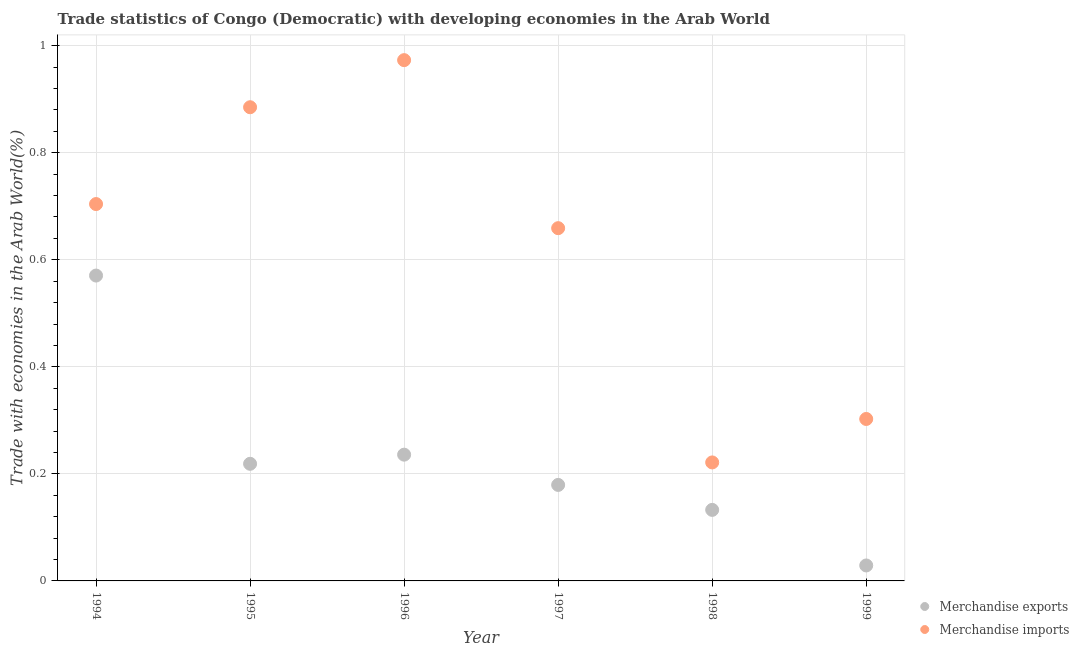What is the merchandise exports in 1999?
Your answer should be very brief. 0.03. Across all years, what is the maximum merchandise imports?
Your answer should be compact. 0.97. Across all years, what is the minimum merchandise exports?
Make the answer very short. 0.03. In which year was the merchandise exports minimum?
Offer a terse response. 1999. What is the total merchandise imports in the graph?
Provide a succinct answer. 3.75. What is the difference between the merchandise imports in 1998 and that in 1999?
Offer a very short reply. -0.08. What is the difference between the merchandise exports in 1994 and the merchandise imports in 1999?
Your answer should be very brief. 0.27. What is the average merchandise exports per year?
Provide a succinct answer. 0.23. In the year 1995, what is the difference between the merchandise exports and merchandise imports?
Your answer should be compact. -0.67. What is the ratio of the merchandise exports in 1996 to that in 1997?
Offer a terse response. 1.32. Is the merchandise imports in 1998 less than that in 1999?
Your answer should be very brief. Yes. What is the difference between the highest and the second highest merchandise imports?
Make the answer very short. 0.09. What is the difference between the highest and the lowest merchandise exports?
Provide a short and direct response. 0.54. Is the sum of the merchandise imports in 1994 and 1998 greater than the maximum merchandise exports across all years?
Offer a very short reply. Yes. Does the merchandise exports monotonically increase over the years?
Offer a very short reply. No. Is the merchandise exports strictly greater than the merchandise imports over the years?
Offer a very short reply. No. How many dotlines are there?
Your response must be concise. 2. How many years are there in the graph?
Make the answer very short. 6. What is the difference between two consecutive major ticks on the Y-axis?
Provide a succinct answer. 0.2. Does the graph contain any zero values?
Provide a short and direct response. No. How many legend labels are there?
Make the answer very short. 2. How are the legend labels stacked?
Provide a succinct answer. Vertical. What is the title of the graph?
Your answer should be compact. Trade statistics of Congo (Democratic) with developing economies in the Arab World. Does "Tetanus" appear as one of the legend labels in the graph?
Your response must be concise. No. What is the label or title of the Y-axis?
Your answer should be very brief. Trade with economies in the Arab World(%). What is the Trade with economies in the Arab World(%) of Merchandise exports in 1994?
Offer a very short reply. 0.57. What is the Trade with economies in the Arab World(%) of Merchandise imports in 1994?
Provide a succinct answer. 0.7. What is the Trade with economies in the Arab World(%) of Merchandise exports in 1995?
Ensure brevity in your answer.  0.22. What is the Trade with economies in the Arab World(%) of Merchandise imports in 1995?
Make the answer very short. 0.89. What is the Trade with economies in the Arab World(%) of Merchandise exports in 1996?
Ensure brevity in your answer.  0.24. What is the Trade with economies in the Arab World(%) in Merchandise imports in 1996?
Offer a terse response. 0.97. What is the Trade with economies in the Arab World(%) in Merchandise exports in 1997?
Offer a very short reply. 0.18. What is the Trade with economies in the Arab World(%) of Merchandise imports in 1997?
Offer a very short reply. 0.66. What is the Trade with economies in the Arab World(%) in Merchandise exports in 1998?
Offer a very short reply. 0.13. What is the Trade with economies in the Arab World(%) in Merchandise imports in 1998?
Your answer should be compact. 0.22. What is the Trade with economies in the Arab World(%) in Merchandise exports in 1999?
Your answer should be very brief. 0.03. What is the Trade with economies in the Arab World(%) of Merchandise imports in 1999?
Provide a succinct answer. 0.3. Across all years, what is the maximum Trade with economies in the Arab World(%) of Merchandise exports?
Keep it short and to the point. 0.57. Across all years, what is the maximum Trade with economies in the Arab World(%) of Merchandise imports?
Your answer should be compact. 0.97. Across all years, what is the minimum Trade with economies in the Arab World(%) in Merchandise exports?
Offer a terse response. 0.03. Across all years, what is the minimum Trade with economies in the Arab World(%) of Merchandise imports?
Offer a very short reply. 0.22. What is the total Trade with economies in the Arab World(%) of Merchandise exports in the graph?
Provide a succinct answer. 1.37. What is the total Trade with economies in the Arab World(%) of Merchandise imports in the graph?
Make the answer very short. 3.75. What is the difference between the Trade with economies in the Arab World(%) of Merchandise exports in 1994 and that in 1995?
Make the answer very short. 0.35. What is the difference between the Trade with economies in the Arab World(%) in Merchandise imports in 1994 and that in 1995?
Offer a very short reply. -0.18. What is the difference between the Trade with economies in the Arab World(%) in Merchandise exports in 1994 and that in 1996?
Your response must be concise. 0.33. What is the difference between the Trade with economies in the Arab World(%) of Merchandise imports in 1994 and that in 1996?
Keep it short and to the point. -0.27. What is the difference between the Trade with economies in the Arab World(%) of Merchandise exports in 1994 and that in 1997?
Offer a terse response. 0.39. What is the difference between the Trade with economies in the Arab World(%) in Merchandise imports in 1994 and that in 1997?
Your answer should be compact. 0.04. What is the difference between the Trade with economies in the Arab World(%) of Merchandise exports in 1994 and that in 1998?
Give a very brief answer. 0.44. What is the difference between the Trade with economies in the Arab World(%) of Merchandise imports in 1994 and that in 1998?
Provide a succinct answer. 0.48. What is the difference between the Trade with economies in the Arab World(%) of Merchandise exports in 1994 and that in 1999?
Give a very brief answer. 0.54. What is the difference between the Trade with economies in the Arab World(%) in Merchandise imports in 1994 and that in 1999?
Make the answer very short. 0.4. What is the difference between the Trade with economies in the Arab World(%) in Merchandise exports in 1995 and that in 1996?
Your answer should be compact. -0.02. What is the difference between the Trade with economies in the Arab World(%) in Merchandise imports in 1995 and that in 1996?
Keep it short and to the point. -0.09. What is the difference between the Trade with economies in the Arab World(%) of Merchandise exports in 1995 and that in 1997?
Provide a succinct answer. 0.04. What is the difference between the Trade with economies in the Arab World(%) of Merchandise imports in 1995 and that in 1997?
Your answer should be compact. 0.23. What is the difference between the Trade with economies in the Arab World(%) of Merchandise exports in 1995 and that in 1998?
Keep it short and to the point. 0.09. What is the difference between the Trade with economies in the Arab World(%) of Merchandise imports in 1995 and that in 1998?
Provide a succinct answer. 0.66. What is the difference between the Trade with economies in the Arab World(%) in Merchandise exports in 1995 and that in 1999?
Your answer should be very brief. 0.19. What is the difference between the Trade with economies in the Arab World(%) of Merchandise imports in 1995 and that in 1999?
Provide a succinct answer. 0.58. What is the difference between the Trade with economies in the Arab World(%) of Merchandise exports in 1996 and that in 1997?
Provide a succinct answer. 0.06. What is the difference between the Trade with economies in the Arab World(%) of Merchandise imports in 1996 and that in 1997?
Offer a terse response. 0.31. What is the difference between the Trade with economies in the Arab World(%) of Merchandise exports in 1996 and that in 1998?
Make the answer very short. 0.1. What is the difference between the Trade with economies in the Arab World(%) of Merchandise imports in 1996 and that in 1998?
Your response must be concise. 0.75. What is the difference between the Trade with economies in the Arab World(%) of Merchandise exports in 1996 and that in 1999?
Provide a short and direct response. 0.21. What is the difference between the Trade with economies in the Arab World(%) of Merchandise imports in 1996 and that in 1999?
Provide a short and direct response. 0.67. What is the difference between the Trade with economies in the Arab World(%) in Merchandise exports in 1997 and that in 1998?
Your answer should be compact. 0.05. What is the difference between the Trade with economies in the Arab World(%) of Merchandise imports in 1997 and that in 1998?
Keep it short and to the point. 0.44. What is the difference between the Trade with economies in the Arab World(%) of Merchandise exports in 1997 and that in 1999?
Your response must be concise. 0.15. What is the difference between the Trade with economies in the Arab World(%) of Merchandise imports in 1997 and that in 1999?
Offer a very short reply. 0.36. What is the difference between the Trade with economies in the Arab World(%) in Merchandise exports in 1998 and that in 1999?
Your answer should be very brief. 0.1. What is the difference between the Trade with economies in the Arab World(%) of Merchandise imports in 1998 and that in 1999?
Provide a short and direct response. -0.08. What is the difference between the Trade with economies in the Arab World(%) in Merchandise exports in 1994 and the Trade with economies in the Arab World(%) in Merchandise imports in 1995?
Give a very brief answer. -0.31. What is the difference between the Trade with economies in the Arab World(%) of Merchandise exports in 1994 and the Trade with economies in the Arab World(%) of Merchandise imports in 1996?
Keep it short and to the point. -0.4. What is the difference between the Trade with economies in the Arab World(%) of Merchandise exports in 1994 and the Trade with economies in the Arab World(%) of Merchandise imports in 1997?
Your answer should be compact. -0.09. What is the difference between the Trade with economies in the Arab World(%) of Merchandise exports in 1994 and the Trade with economies in the Arab World(%) of Merchandise imports in 1998?
Keep it short and to the point. 0.35. What is the difference between the Trade with economies in the Arab World(%) of Merchandise exports in 1994 and the Trade with economies in the Arab World(%) of Merchandise imports in 1999?
Provide a succinct answer. 0.27. What is the difference between the Trade with economies in the Arab World(%) in Merchandise exports in 1995 and the Trade with economies in the Arab World(%) in Merchandise imports in 1996?
Give a very brief answer. -0.75. What is the difference between the Trade with economies in the Arab World(%) of Merchandise exports in 1995 and the Trade with economies in the Arab World(%) of Merchandise imports in 1997?
Provide a succinct answer. -0.44. What is the difference between the Trade with economies in the Arab World(%) of Merchandise exports in 1995 and the Trade with economies in the Arab World(%) of Merchandise imports in 1998?
Your answer should be compact. -0. What is the difference between the Trade with economies in the Arab World(%) of Merchandise exports in 1995 and the Trade with economies in the Arab World(%) of Merchandise imports in 1999?
Your answer should be compact. -0.08. What is the difference between the Trade with economies in the Arab World(%) in Merchandise exports in 1996 and the Trade with economies in the Arab World(%) in Merchandise imports in 1997?
Your response must be concise. -0.42. What is the difference between the Trade with economies in the Arab World(%) of Merchandise exports in 1996 and the Trade with economies in the Arab World(%) of Merchandise imports in 1998?
Provide a short and direct response. 0.01. What is the difference between the Trade with economies in the Arab World(%) of Merchandise exports in 1996 and the Trade with economies in the Arab World(%) of Merchandise imports in 1999?
Keep it short and to the point. -0.07. What is the difference between the Trade with economies in the Arab World(%) in Merchandise exports in 1997 and the Trade with economies in the Arab World(%) in Merchandise imports in 1998?
Your answer should be very brief. -0.04. What is the difference between the Trade with economies in the Arab World(%) in Merchandise exports in 1997 and the Trade with economies in the Arab World(%) in Merchandise imports in 1999?
Give a very brief answer. -0.12. What is the difference between the Trade with economies in the Arab World(%) of Merchandise exports in 1998 and the Trade with economies in the Arab World(%) of Merchandise imports in 1999?
Keep it short and to the point. -0.17. What is the average Trade with economies in the Arab World(%) in Merchandise exports per year?
Provide a short and direct response. 0.23. What is the average Trade with economies in the Arab World(%) in Merchandise imports per year?
Offer a very short reply. 0.62. In the year 1994, what is the difference between the Trade with economies in the Arab World(%) in Merchandise exports and Trade with economies in the Arab World(%) in Merchandise imports?
Your answer should be very brief. -0.13. In the year 1995, what is the difference between the Trade with economies in the Arab World(%) in Merchandise exports and Trade with economies in the Arab World(%) in Merchandise imports?
Provide a short and direct response. -0.67. In the year 1996, what is the difference between the Trade with economies in the Arab World(%) of Merchandise exports and Trade with economies in the Arab World(%) of Merchandise imports?
Your answer should be compact. -0.74. In the year 1997, what is the difference between the Trade with economies in the Arab World(%) in Merchandise exports and Trade with economies in the Arab World(%) in Merchandise imports?
Give a very brief answer. -0.48. In the year 1998, what is the difference between the Trade with economies in the Arab World(%) in Merchandise exports and Trade with economies in the Arab World(%) in Merchandise imports?
Offer a very short reply. -0.09. In the year 1999, what is the difference between the Trade with economies in the Arab World(%) in Merchandise exports and Trade with economies in the Arab World(%) in Merchandise imports?
Provide a succinct answer. -0.27. What is the ratio of the Trade with economies in the Arab World(%) of Merchandise exports in 1994 to that in 1995?
Keep it short and to the point. 2.61. What is the ratio of the Trade with economies in the Arab World(%) in Merchandise imports in 1994 to that in 1995?
Keep it short and to the point. 0.8. What is the ratio of the Trade with economies in the Arab World(%) in Merchandise exports in 1994 to that in 1996?
Provide a short and direct response. 2.42. What is the ratio of the Trade with economies in the Arab World(%) of Merchandise imports in 1994 to that in 1996?
Your response must be concise. 0.72. What is the ratio of the Trade with economies in the Arab World(%) of Merchandise exports in 1994 to that in 1997?
Your answer should be compact. 3.18. What is the ratio of the Trade with economies in the Arab World(%) of Merchandise imports in 1994 to that in 1997?
Offer a very short reply. 1.07. What is the ratio of the Trade with economies in the Arab World(%) in Merchandise exports in 1994 to that in 1998?
Offer a terse response. 4.3. What is the ratio of the Trade with economies in the Arab World(%) of Merchandise imports in 1994 to that in 1998?
Keep it short and to the point. 3.18. What is the ratio of the Trade with economies in the Arab World(%) in Merchandise exports in 1994 to that in 1999?
Offer a terse response. 19.74. What is the ratio of the Trade with economies in the Arab World(%) in Merchandise imports in 1994 to that in 1999?
Provide a succinct answer. 2.33. What is the ratio of the Trade with economies in the Arab World(%) in Merchandise exports in 1995 to that in 1996?
Offer a terse response. 0.93. What is the ratio of the Trade with economies in the Arab World(%) in Merchandise imports in 1995 to that in 1996?
Make the answer very short. 0.91. What is the ratio of the Trade with economies in the Arab World(%) of Merchandise exports in 1995 to that in 1997?
Your answer should be compact. 1.22. What is the ratio of the Trade with economies in the Arab World(%) of Merchandise imports in 1995 to that in 1997?
Your response must be concise. 1.34. What is the ratio of the Trade with economies in the Arab World(%) in Merchandise exports in 1995 to that in 1998?
Ensure brevity in your answer.  1.65. What is the ratio of the Trade with economies in the Arab World(%) of Merchandise imports in 1995 to that in 1998?
Offer a very short reply. 4. What is the ratio of the Trade with economies in the Arab World(%) in Merchandise exports in 1995 to that in 1999?
Offer a terse response. 7.57. What is the ratio of the Trade with economies in the Arab World(%) of Merchandise imports in 1995 to that in 1999?
Your answer should be compact. 2.92. What is the ratio of the Trade with economies in the Arab World(%) in Merchandise exports in 1996 to that in 1997?
Ensure brevity in your answer.  1.32. What is the ratio of the Trade with economies in the Arab World(%) of Merchandise imports in 1996 to that in 1997?
Give a very brief answer. 1.48. What is the ratio of the Trade with economies in the Arab World(%) of Merchandise exports in 1996 to that in 1998?
Ensure brevity in your answer.  1.78. What is the ratio of the Trade with economies in the Arab World(%) in Merchandise imports in 1996 to that in 1998?
Keep it short and to the point. 4.39. What is the ratio of the Trade with economies in the Arab World(%) in Merchandise exports in 1996 to that in 1999?
Your answer should be compact. 8.16. What is the ratio of the Trade with economies in the Arab World(%) of Merchandise imports in 1996 to that in 1999?
Make the answer very short. 3.22. What is the ratio of the Trade with economies in the Arab World(%) of Merchandise exports in 1997 to that in 1998?
Offer a very short reply. 1.35. What is the ratio of the Trade with economies in the Arab World(%) of Merchandise imports in 1997 to that in 1998?
Your answer should be compact. 2.98. What is the ratio of the Trade with economies in the Arab World(%) in Merchandise exports in 1997 to that in 1999?
Offer a very short reply. 6.21. What is the ratio of the Trade with economies in the Arab World(%) of Merchandise imports in 1997 to that in 1999?
Keep it short and to the point. 2.18. What is the ratio of the Trade with economies in the Arab World(%) of Merchandise exports in 1998 to that in 1999?
Your answer should be compact. 4.59. What is the ratio of the Trade with economies in the Arab World(%) in Merchandise imports in 1998 to that in 1999?
Provide a succinct answer. 0.73. What is the difference between the highest and the second highest Trade with economies in the Arab World(%) of Merchandise exports?
Keep it short and to the point. 0.33. What is the difference between the highest and the second highest Trade with economies in the Arab World(%) of Merchandise imports?
Offer a terse response. 0.09. What is the difference between the highest and the lowest Trade with economies in the Arab World(%) in Merchandise exports?
Provide a short and direct response. 0.54. What is the difference between the highest and the lowest Trade with economies in the Arab World(%) in Merchandise imports?
Ensure brevity in your answer.  0.75. 